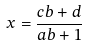Convert formula to latex. <formula><loc_0><loc_0><loc_500><loc_500>x = \frac { c b + d } { a b + 1 }</formula> 